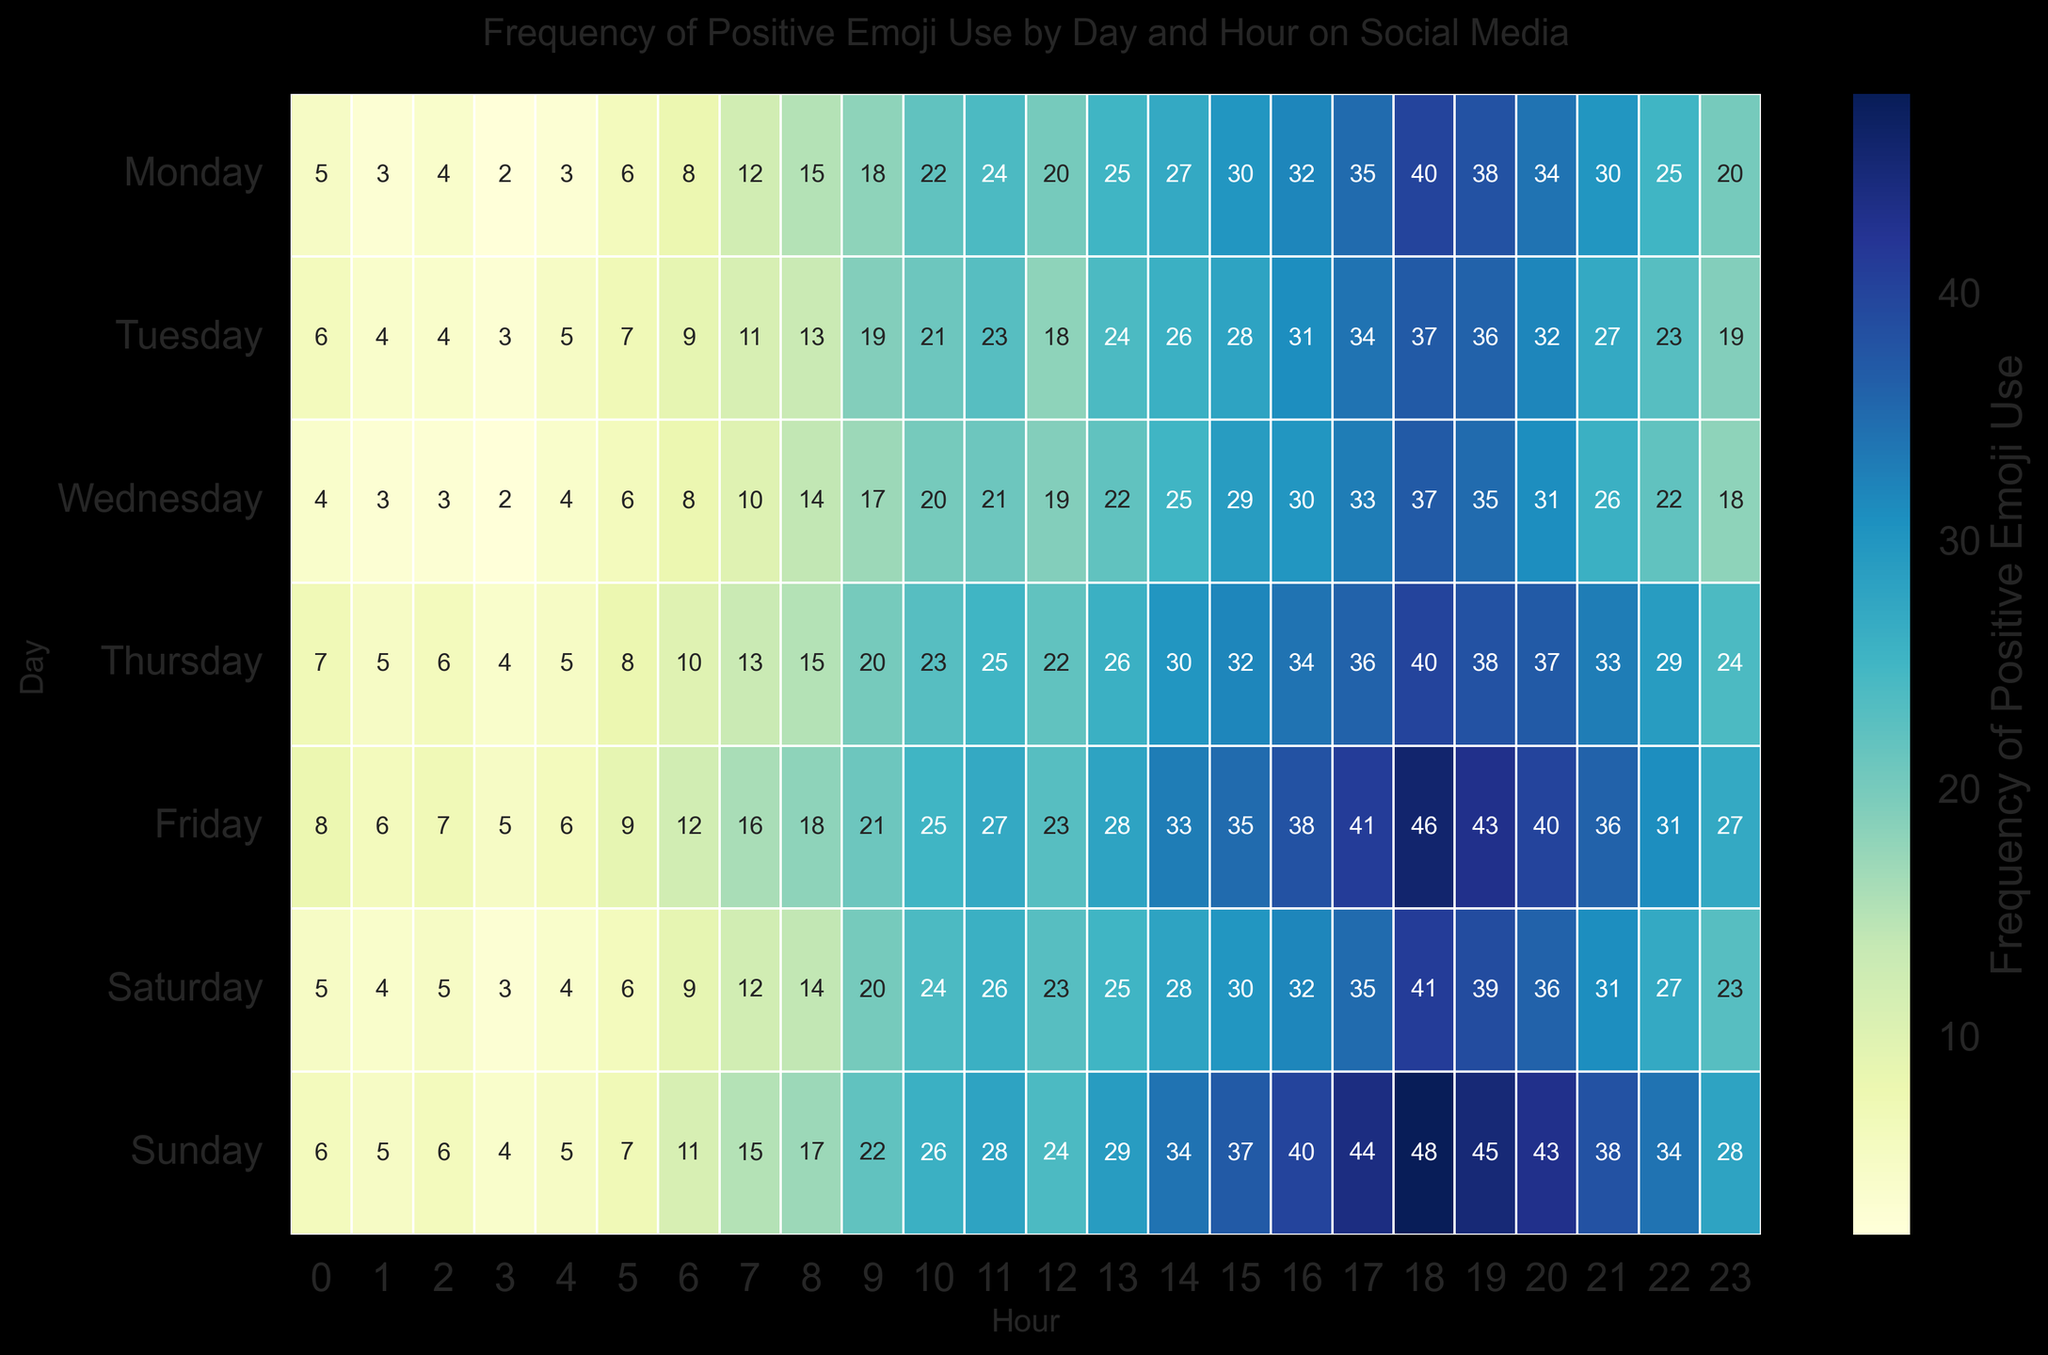Which day has the highest overall frequency of positive emoji use? By analyzing the color intensity in the heatmap, Sunday shows the darkest shades, indicating the highest frequency of positive emoji use.
Answer: Sunday What is the difference in the frequency of positive emoji use between 18:00 on Friday and 18:00 on Monday? The frequency at 18:00 on Friday is 46, and at 18:00 on Monday is 40. The difference is calculated as 46 - 40.
Answer: 6 On which day and hour is the use of positive emojis lowest? The heatmap shows the lightest color at 3:00 on Monday and Wednesday, indicating the lowest frequencies of 2.
Answer: Monday/Wednesday at 3:00 Compare the frequency of positive emoji use at 12:00 on Wednesday and 12:00 on Sunday. Which one is higher? The frequency at 12:00 on Wednesday is 19, and at 12:00 on Sunday is 24. Sunday at 12:00 has a higher frequency.
Answer: Sunday at 12:00 How does the frequency of positive emoji use change from 15:00 to 18:00 on Saturday? From 15:00, the frequencies are 30, 32, 35, and then 41 at 18:00. The pattern shows an increasing trend.
Answer: Increasing What is the average frequency of positive emoji use from 9:00 to 12:00 on Tuesday? The frequencies from 9:00 to 12:00 are 19, 21, 23, and 18. Their sum is 81, and the average is 81/4.
Answer: 20.25 Which hour shows the highest frequency of positive emoji use across the entire week? Analyzing the darkest color spots, 18:00 on Sunday has the highest value at 48.
Answer: 18:00 Sunday Is there any day where the frequency peaks twice during the day? By observing the heatmap's color patterns, Sunday shows notable peaks both at 18:00 (48) and 17:00 (44), indicating peaks at two different times.
Answer: Yes, Sunday What is the trend of emoji use from 20:00 to 23:00 on Thursday? From 20:00 to 23:00 on Thursday, the frequencies are 37, 33, 29, and 24, indicating a decreasing trend.
Answer: Decreasing Compare the frequency of emoji use at 18:00 and 20:00 on Wednesday. Which one is greater and by how much? The frequency at 18:00 on Wednesday is 37, and at 20:00, it is 31. The difference is 37 - 31.
Answer: 18:00 by 6 